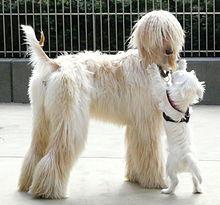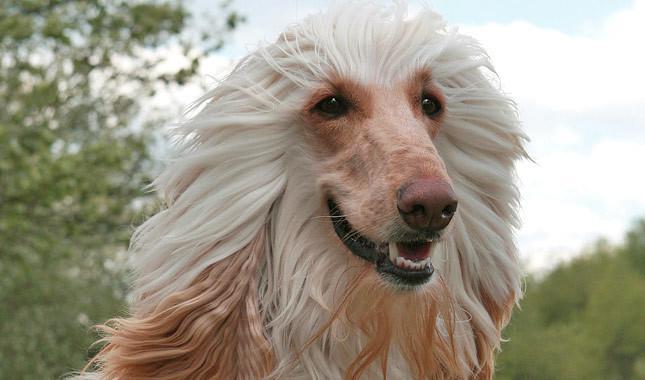The first image is the image on the left, the second image is the image on the right. Assess this claim about the two images: "One image features at least two dogs.". Correct or not? Answer yes or no. Yes. 